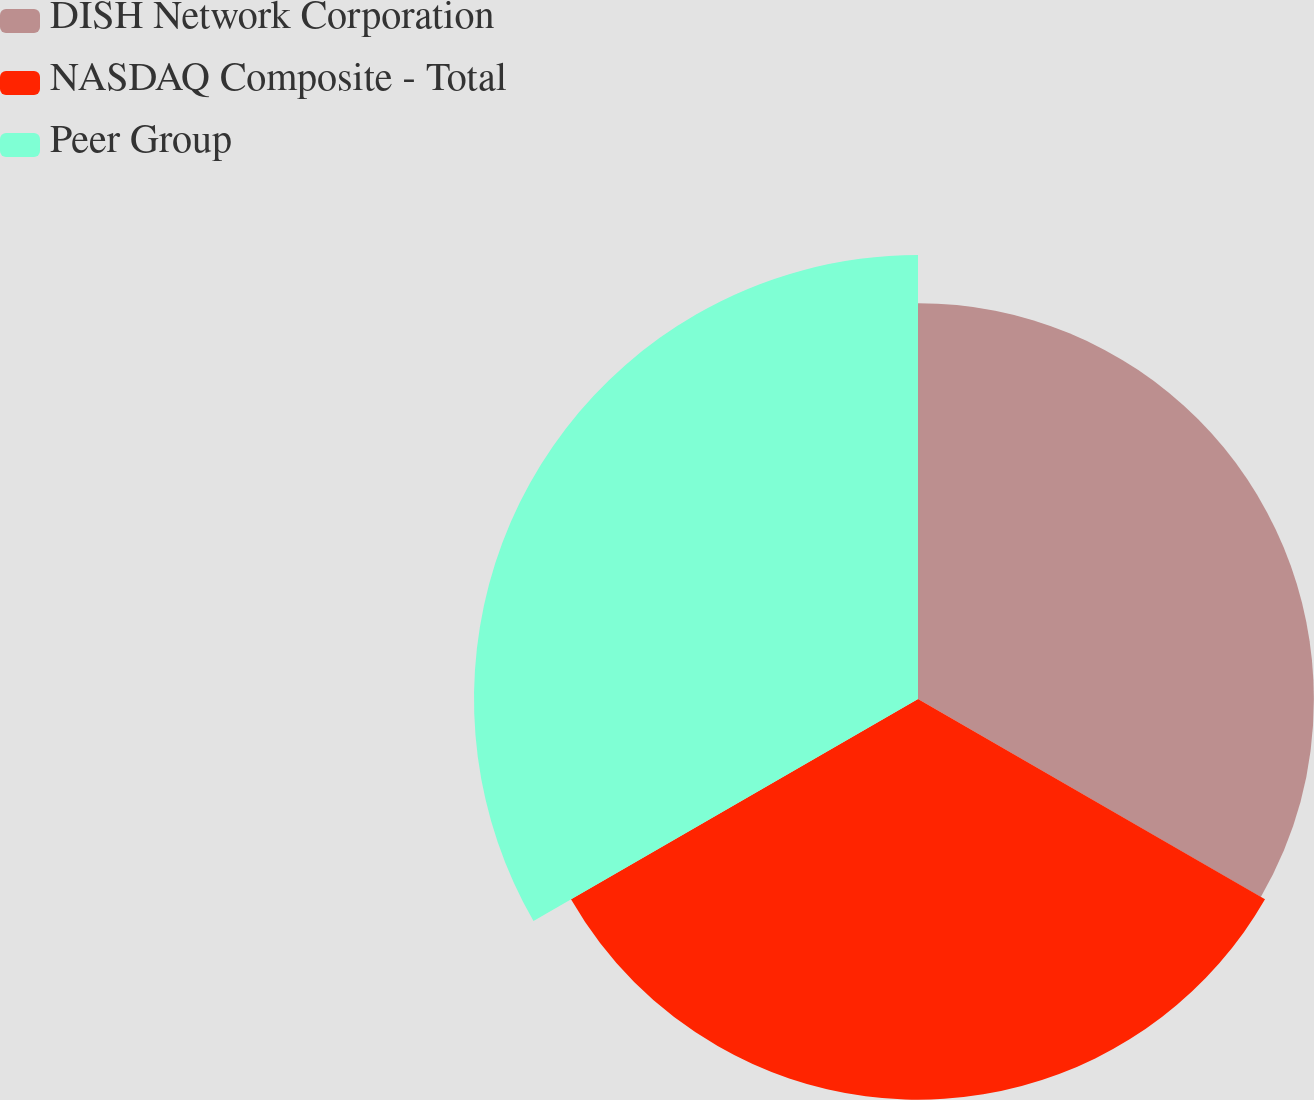Convert chart to OTSL. <chart><loc_0><loc_0><loc_500><loc_500><pie_chart><fcel>DISH Network Corporation<fcel>NASDAQ Composite - Total<fcel>Peer Group<nl><fcel>31.91%<fcel>32.3%<fcel>35.79%<nl></chart> 